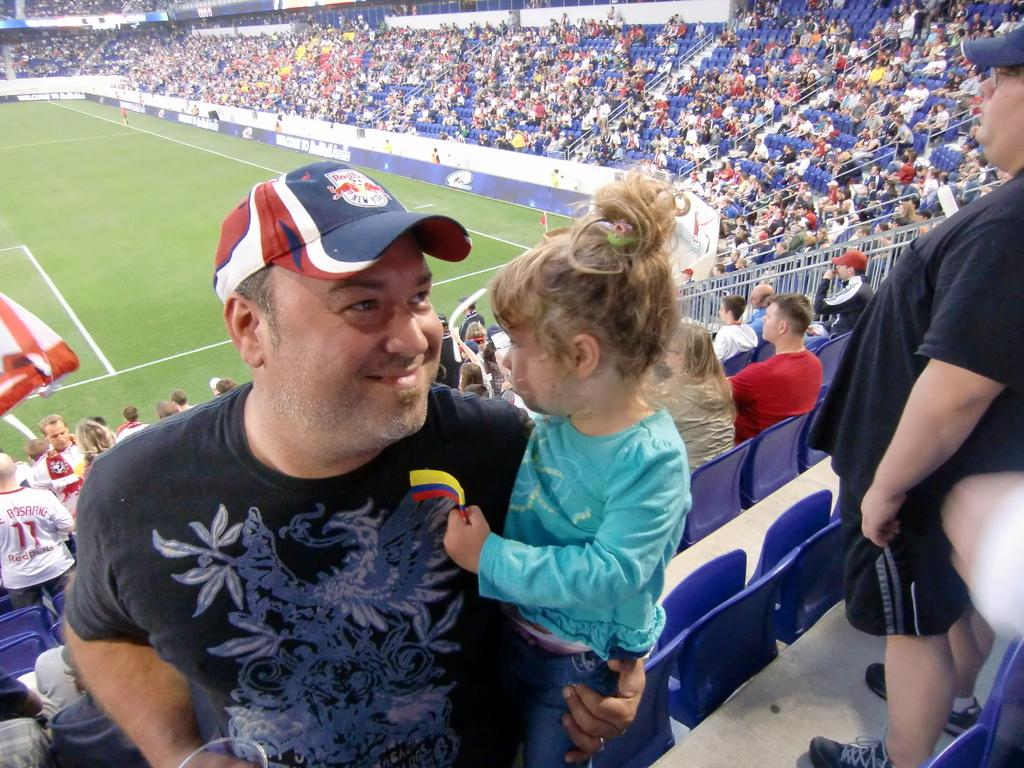Where was the image taken? The image was taken in a stadium. What can be seen in the foreground of the image? There is a man holding a child in the front of the image. What is visible in the background of the image? There is a crowd in the background of the image. What type of surface is visible to the left of the image? There is a ground with grass to the left of the image. Can you see a squirrel climbing up a plastic stem in the image? No, there is no squirrel or plastic stem present in the image. 